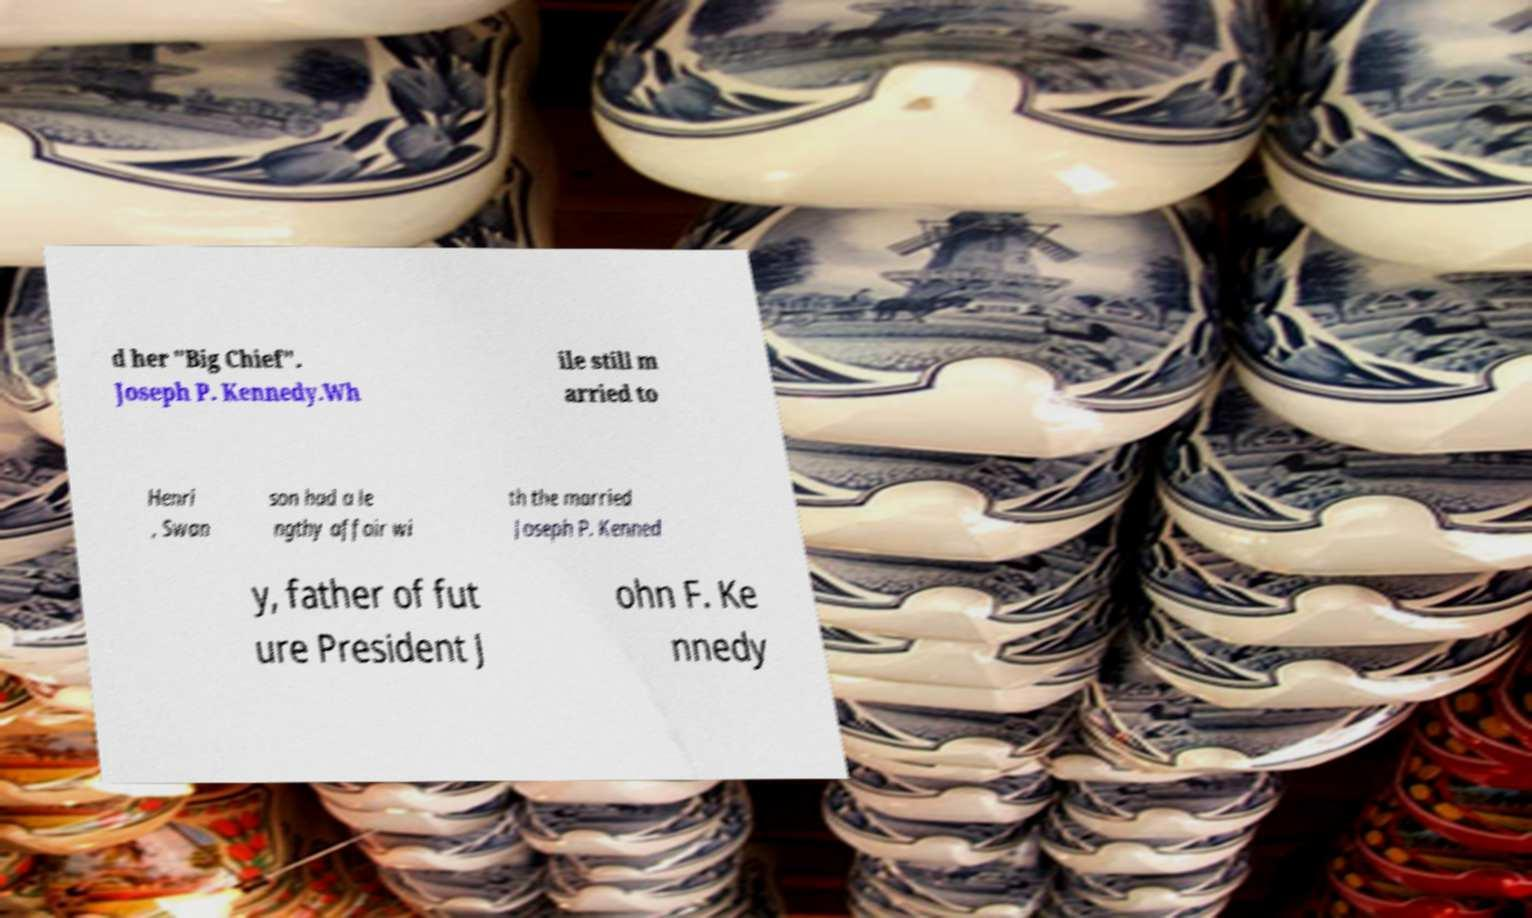I need the written content from this picture converted into text. Can you do that? d her "Big Chief". Joseph P. Kennedy.Wh ile still m arried to Henri , Swan son had a le ngthy affair wi th the married Joseph P. Kenned y, father of fut ure President J ohn F. Ke nnedy 